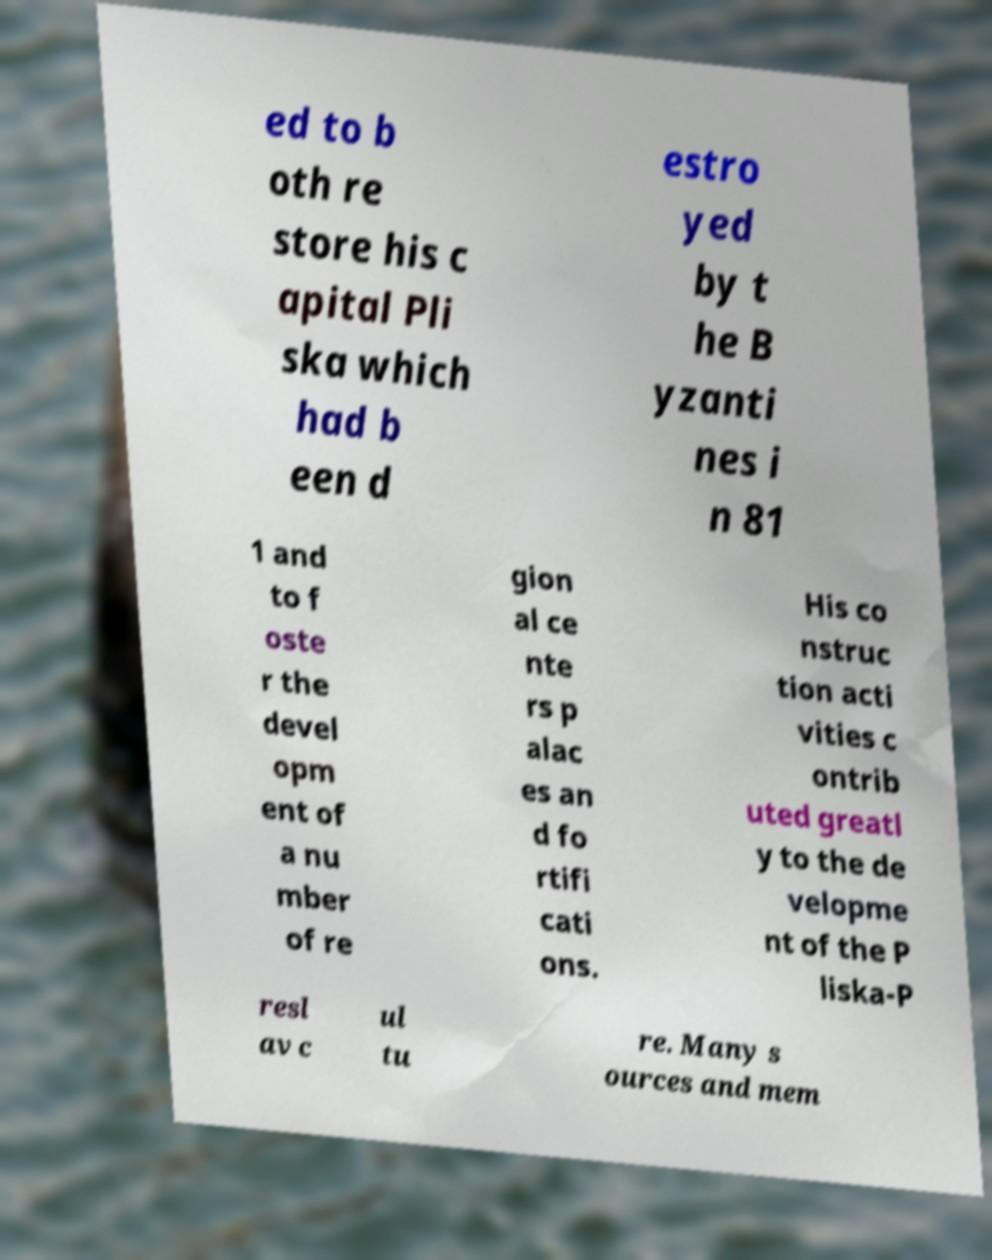What messages or text are displayed in this image? I need them in a readable, typed format. ed to b oth re store his c apital Pli ska which had b een d estro yed by t he B yzanti nes i n 81 1 and to f oste r the devel opm ent of a nu mber of re gion al ce nte rs p alac es an d fo rtifi cati ons. His co nstruc tion acti vities c ontrib uted greatl y to the de velopme nt of the P liska-P resl av c ul tu re. Many s ources and mem 